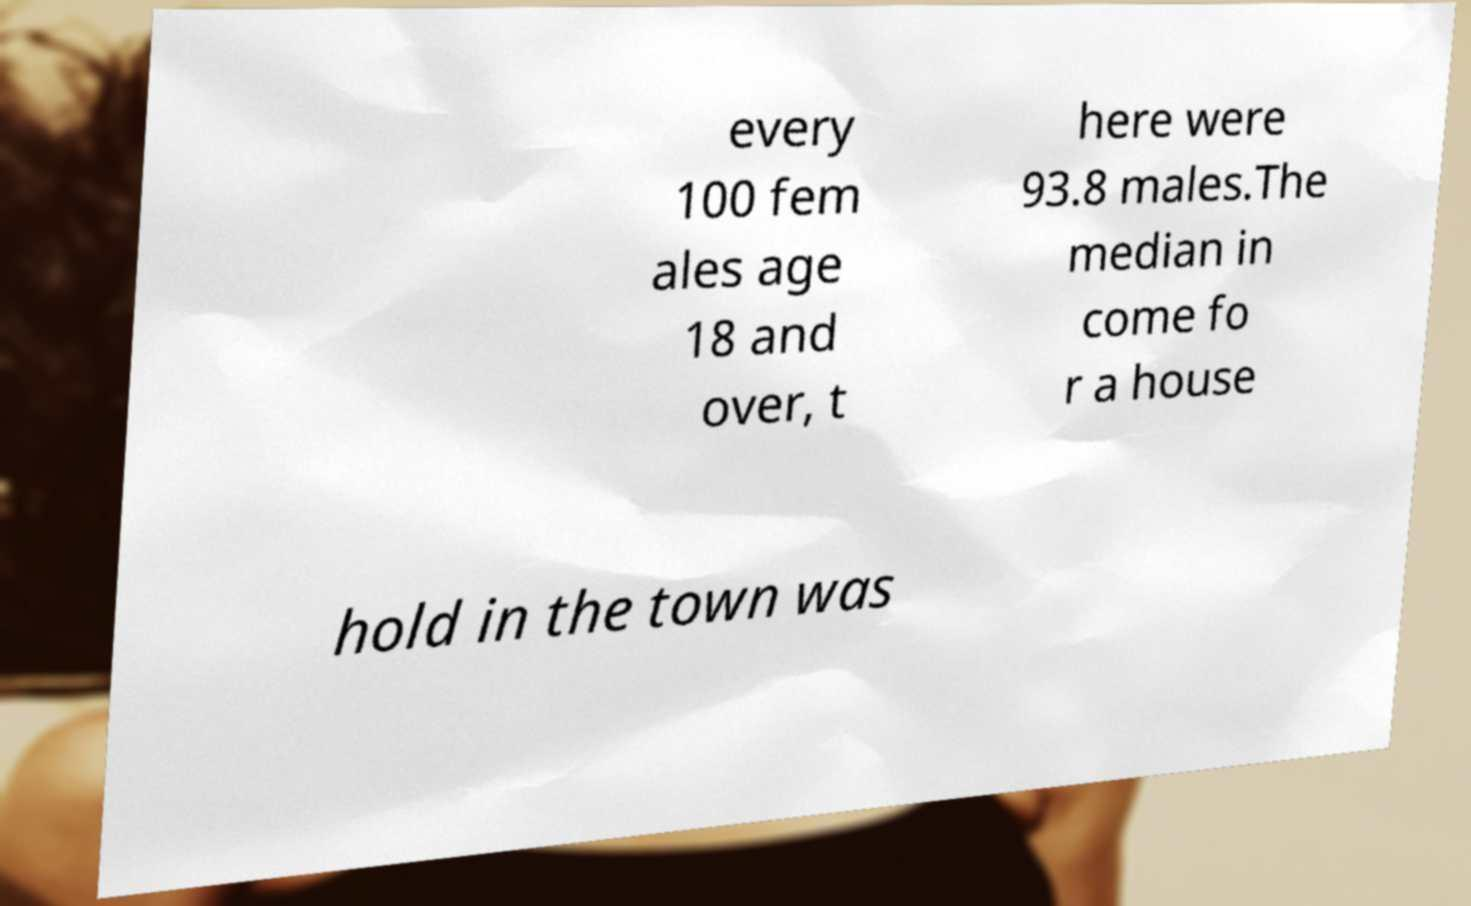Could you assist in decoding the text presented in this image and type it out clearly? every 100 fem ales age 18 and over, t here were 93.8 males.The median in come fo r a house hold in the town was 